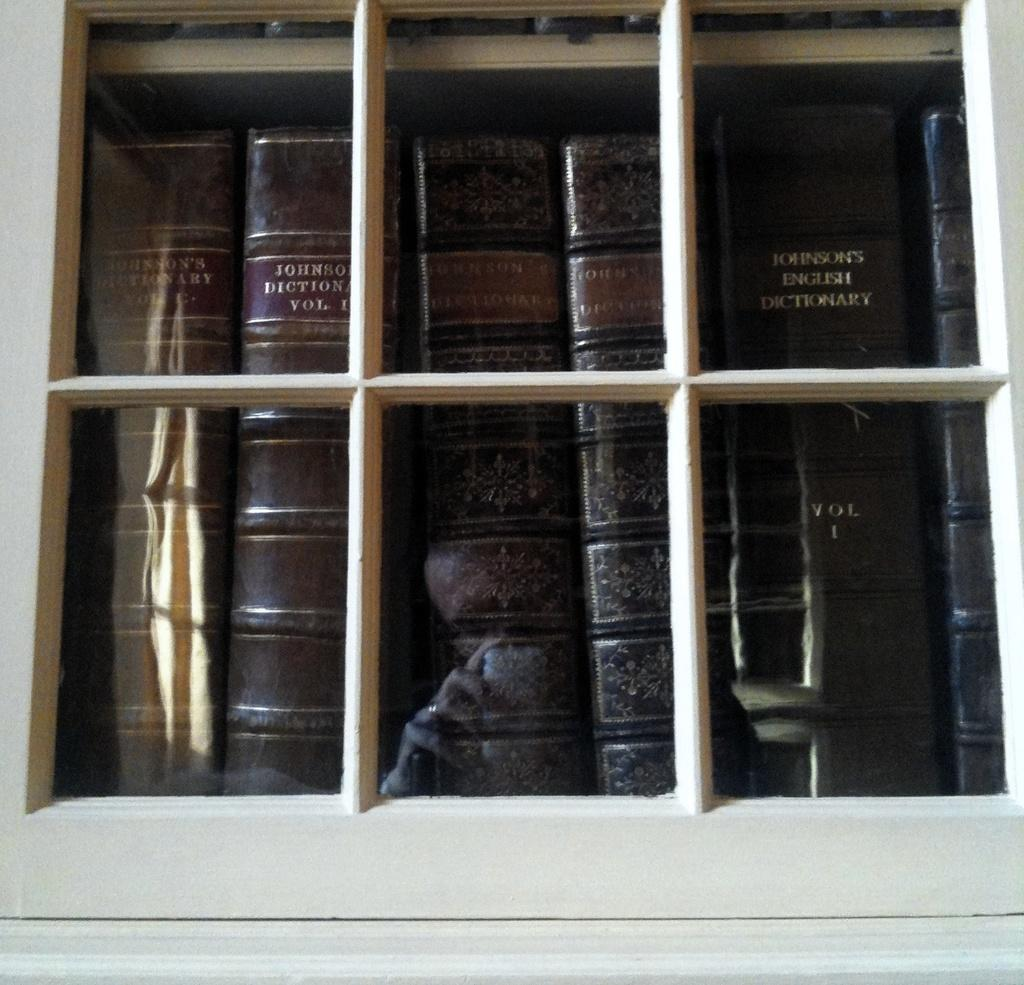Provide a one-sentence caption for the provided image. Brown books behind a window including one that says Vol 1. 